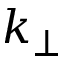<formula> <loc_0><loc_0><loc_500><loc_500>k _ { \perp }</formula> 